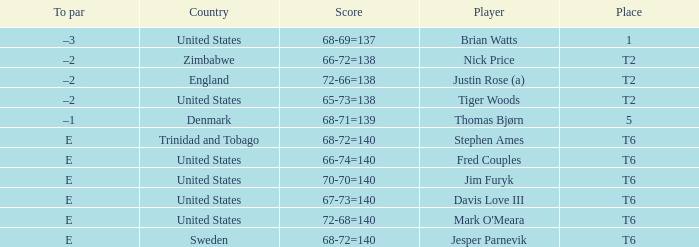What was the TO par for the player who scored 68-71=139? –1. 